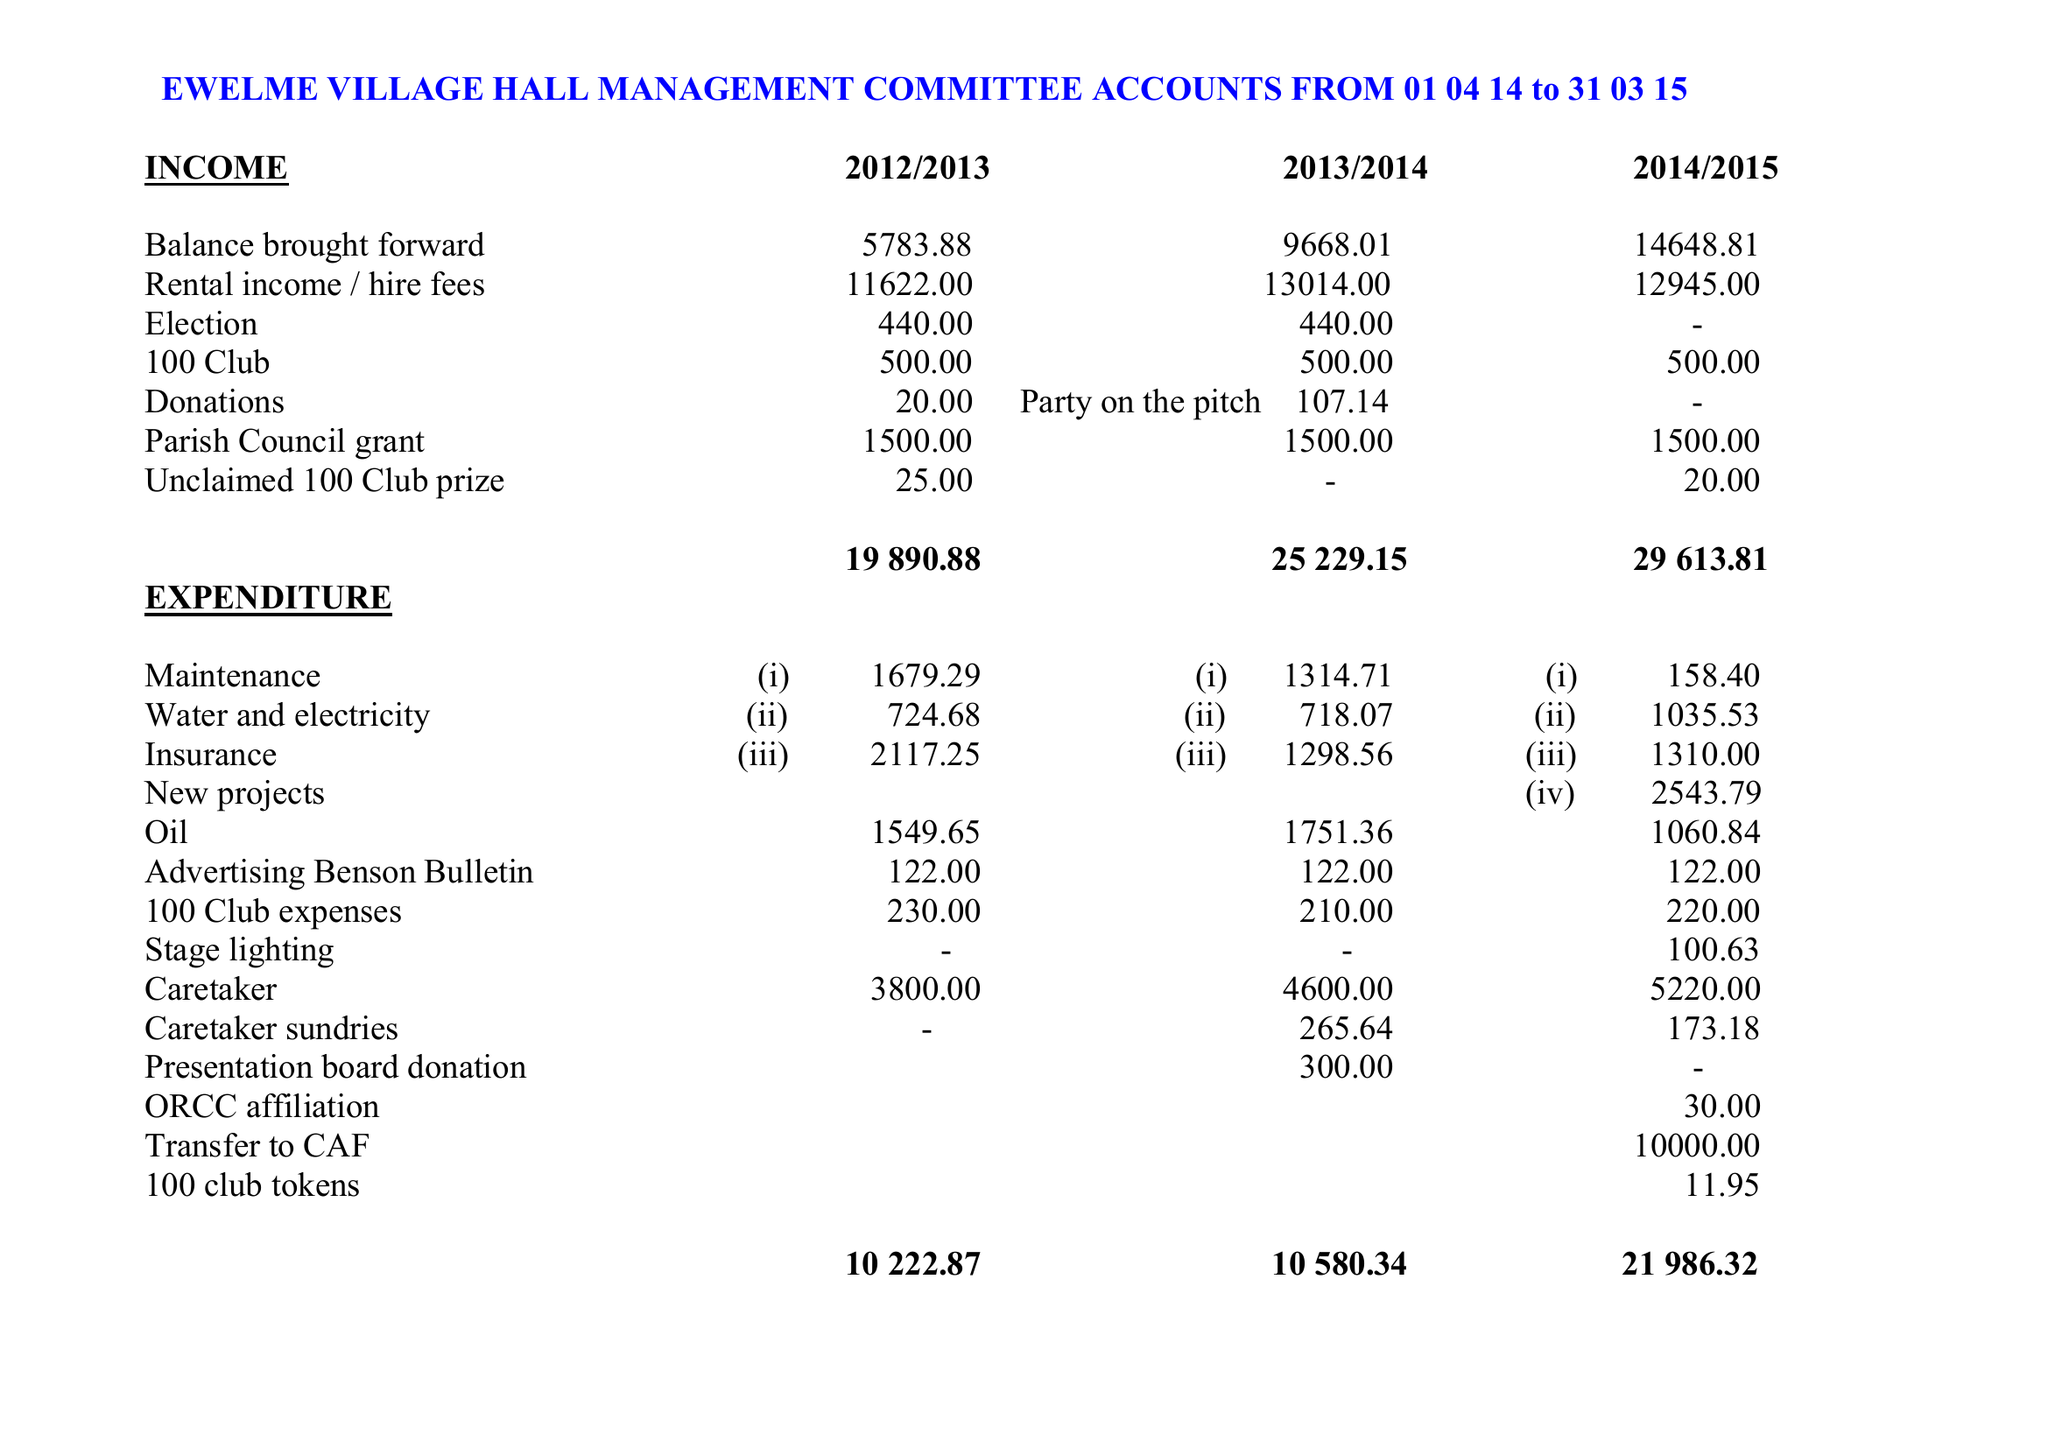What is the value for the address__post_town?
Answer the question using a single word or phrase. WALLINGFORD 